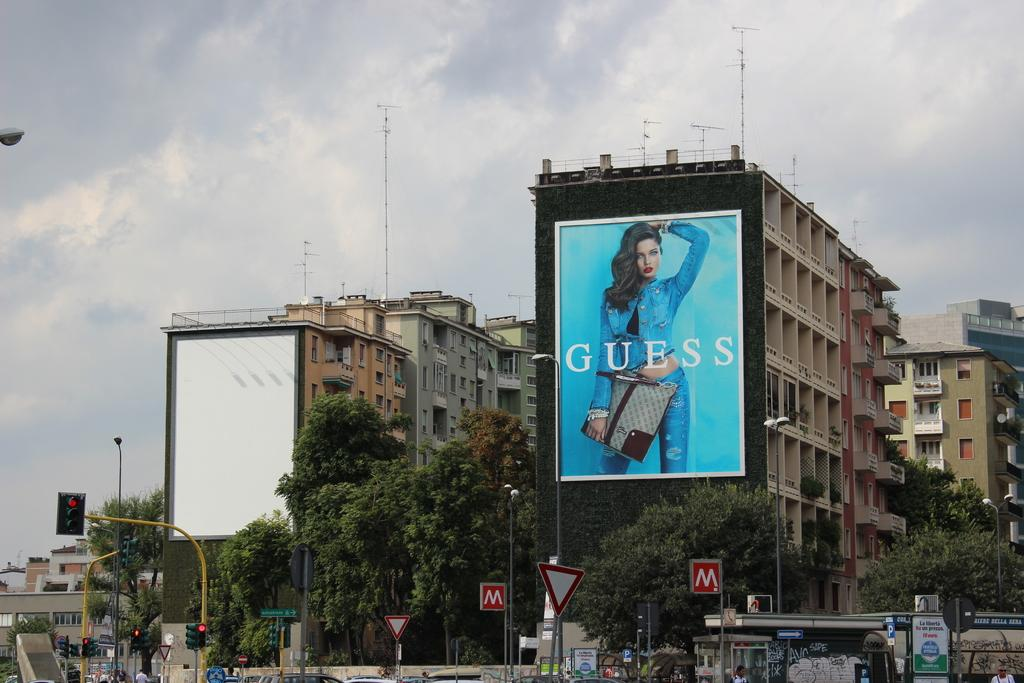Provide a one-sentence caption for the provided image. A large ad for Guess is covering an entire apartment building. 